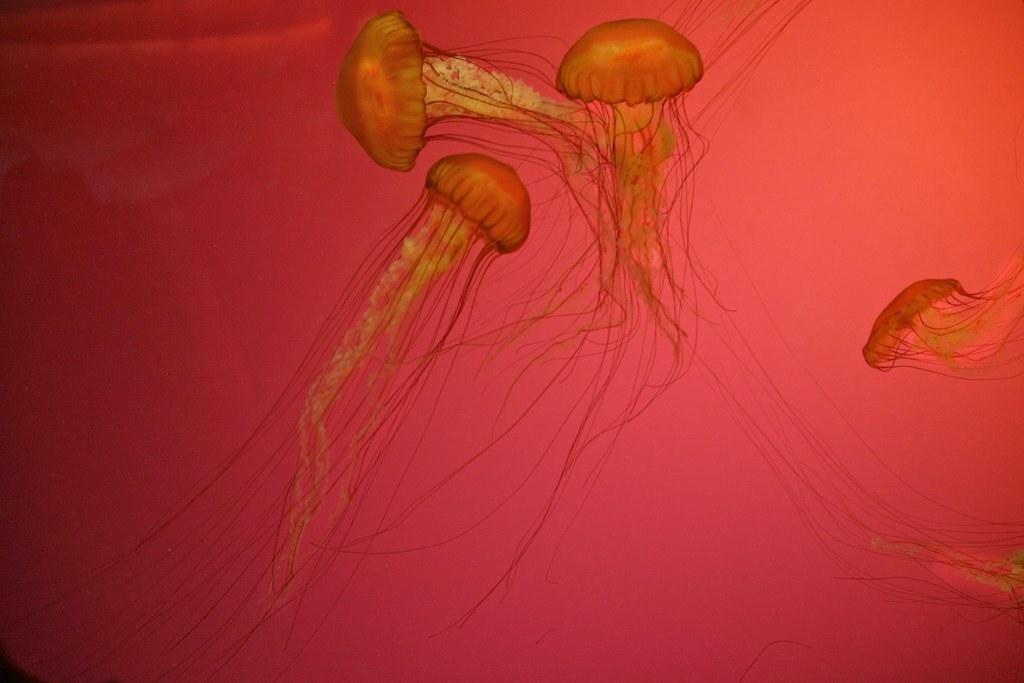How would you summarize this image in a sentence or two? In this picture we can see few jellyfish. 